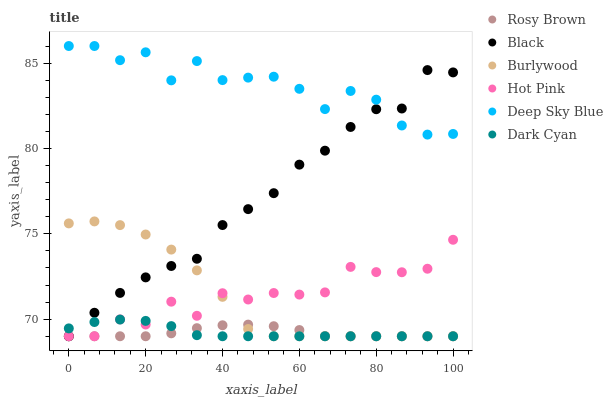Does Rosy Brown have the minimum area under the curve?
Answer yes or no. Yes. Does Deep Sky Blue have the maximum area under the curve?
Answer yes or no. Yes. Does Burlywood have the minimum area under the curve?
Answer yes or no. No. Does Burlywood have the maximum area under the curve?
Answer yes or no. No. Is Rosy Brown the smoothest?
Answer yes or no. Yes. Is Deep Sky Blue the roughest?
Answer yes or no. Yes. Is Burlywood the smoothest?
Answer yes or no. No. Is Burlywood the roughest?
Answer yes or no. No. Does Hot Pink have the lowest value?
Answer yes or no. Yes. Does Deep Sky Blue have the lowest value?
Answer yes or no. No. Does Deep Sky Blue have the highest value?
Answer yes or no. Yes. Does Burlywood have the highest value?
Answer yes or no. No. Is Burlywood less than Deep Sky Blue?
Answer yes or no. Yes. Is Deep Sky Blue greater than Burlywood?
Answer yes or no. Yes. Does Burlywood intersect Black?
Answer yes or no. Yes. Is Burlywood less than Black?
Answer yes or no. No. Is Burlywood greater than Black?
Answer yes or no. No. Does Burlywood intersect Deep Sky Blue?
Answer yes or no. No. 